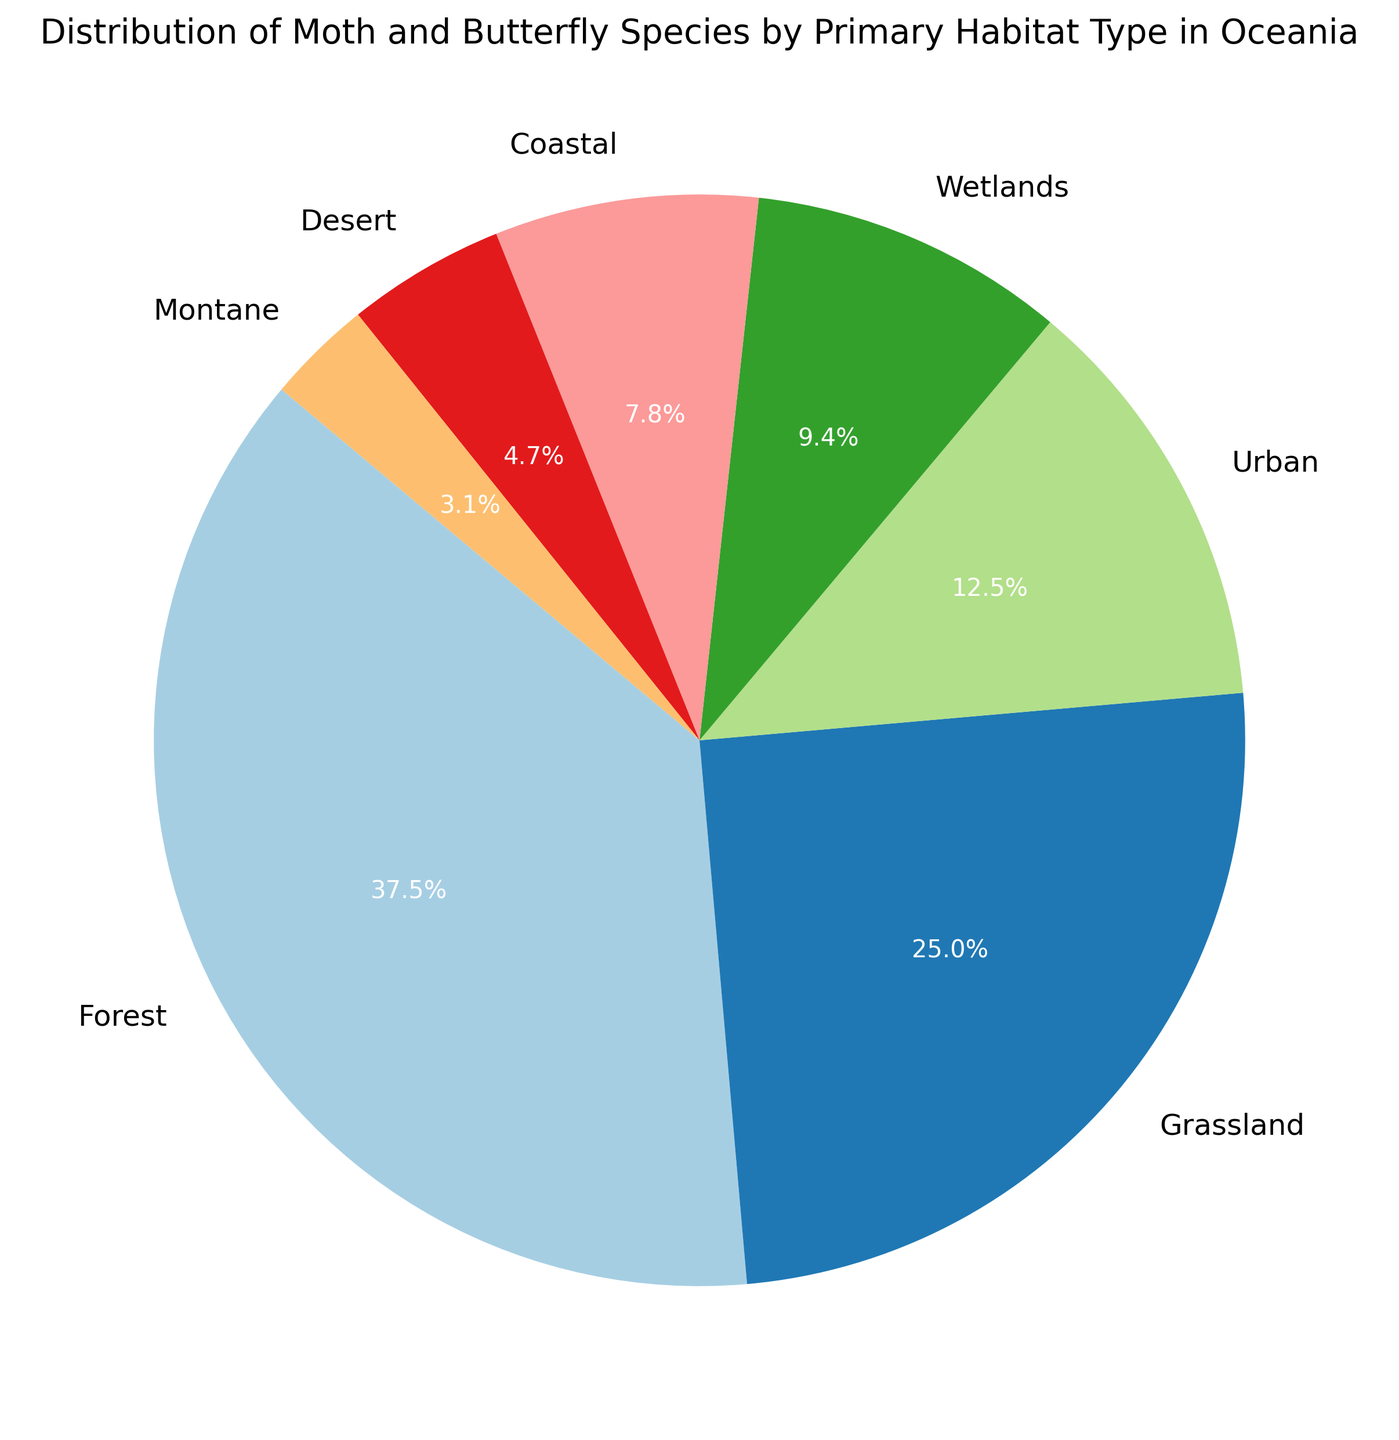Which habitat type has the highest distribution of moth and butterfly species? Look at the pie chart and identify the largest section. The Forest section occupies the largest portion of the pie chart.
Answer: Forest Which habitat has twice the species count compared to Urban areas? Identify the Habitat section in the pie chart for Urban, and then find the section that approximately doubles the species count of Urban. Urban has 40 species, and Grassland has 80 species.
Answer: Grassland What percentage of species are found in coastal habitats? Check the label for the Coastal section in the pie chart. The label shows 7.0%.
Answer: 7.0% How does the species distribution in Grasslands compare to Forests? Check the proportions represented in the pie chart for both Grasslands and Forests. Grasslands (80 species) is 66.7% (or two-thirds) of the number in Forests (120 species), which is the largest portion.
Answer: Grasslands have fewer species than Forests Is the number of species in Urban areas more, less, or equal to the combined number of species in Montane and Desert areas? Sum the species in Montane and Desert (10 + 15 = 25) and compare it to the number in Urban (40). Urban has more species (40 > 25).
Answer: More What is the combined percentage of species found in Coastal and Wetlands habitats? Add the percentages from the Coastal and Wetlands sections of the pie chart. Coastal is 7.0%, and Wetlands is 8.8%. Combined, it is 7.0 + 8.8 = 15.8%.
Answer: 15.8% How many more species are found in Forests compared to Deserts? Subtract the number of species in Deserts from the number of species in Forests (120 - 15 = 105).
Answer: 105 What is the average species count for all listed habitats? Add the species counts for all habitats and divide by the number of habitats (120 + 80 + 40 + 30 + 25 + 15 + 10 = 320; 320 / 7 ≈ 45.7).
Answer: 45.7 Which habitats have a species count that is less than the average species count? First calculate the average species count (approx. 45.7). Then identify the habitats with counts less than 45. They are Urban (40), Wetlands (30), Coastal (25), Desert (15), and Montane (10).
Answer: Urban, Wetlands, Coastal, Desert, Montane What is the difference in species count between the second-largest and the smallest habitat type? Identify the second-largest habitat (Grassland) and the smallest habitat (Montane). Grassland has 80 species and Montane has 10. The difference is 80 - 10 = 70.
Answer: 70 